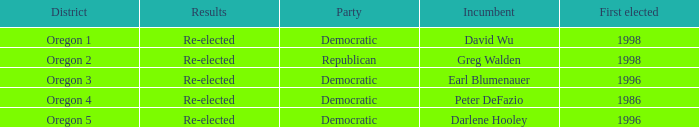Which district has a Democratic incumbent that was first elected before 1996? Oregon 4. 